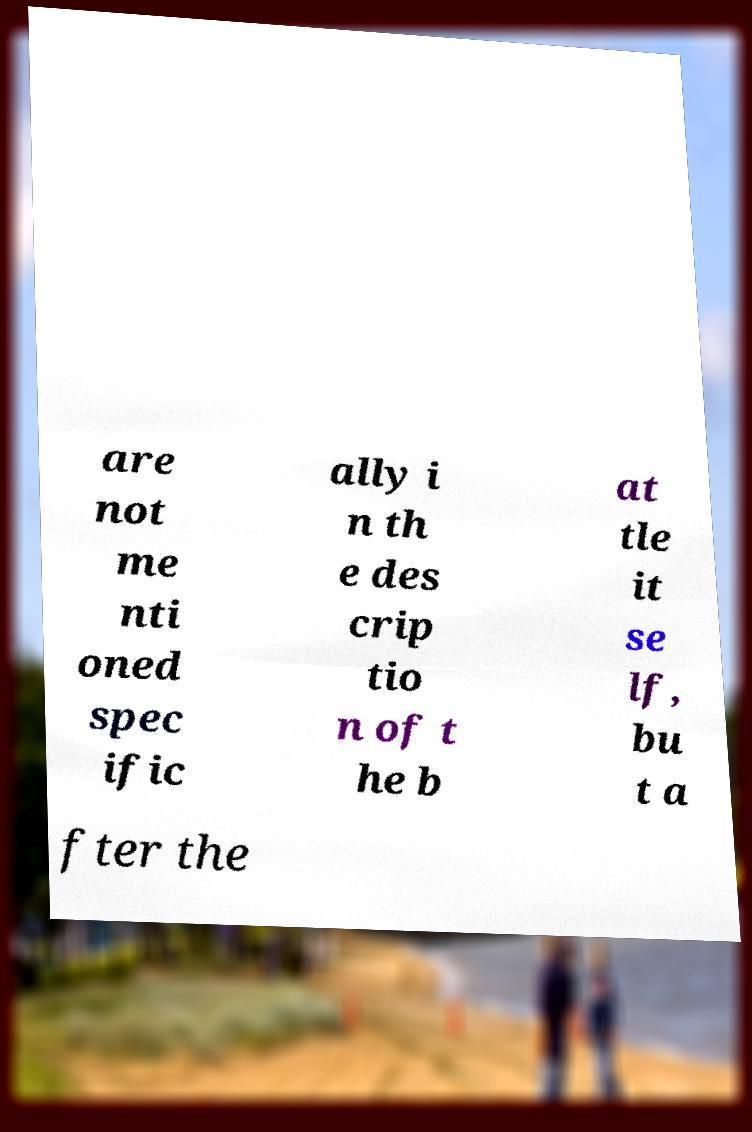Could you assist in decoding the text presented in this image and type it out clearly? are not me nti oned spec ific ally i n th e des crip tio n of t he b at tle it se lf, bu t a fter the 